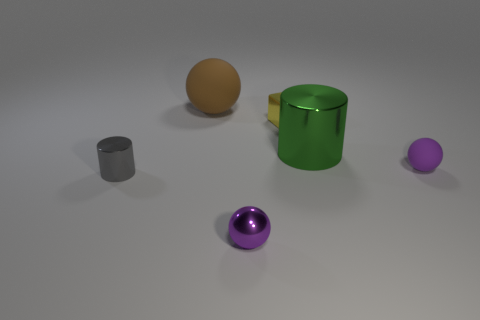What material is the other large thing that is the same shape as the gray thing?
Provide a succinct answer. Metal. There is a shiny object in front of the tiny gray object; what is its shape?
Your answer should be very brief. Sphere. Are there any big purple cylinders made of the same material as the gray cylinder?
Offer a terse response. No. Is the purple metal thing the same size as the brown sphere?
Your response must be concise. No. How many cylinders are either tiny green objects or purple rubber things?
Provide a succinct answer. 0. There is a thing that is the same color as the shiny ball; what material is it?
Provide a short and direct response. Rubber. How many yellow matte things have the same shape as the large green shiny object?
Your answer should be very brief. 0. Is the number of gray cylinders that are to the left of the small matte ball greater than the number of small purple metal spheres on the right side of the small shiny ball?
Provide a succinct answer. Yes. There is a large thing in front of the tiny block; does it have the same color as the tiny cylinder?
Offer a very short reply. No. How big is the metallic sphere?
Provide a short and direct response. Small. 